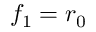<formula> <loc_0><loc_0><loc_500><loc_500>f _ { 1 } = r _ { 0 }</formula> 